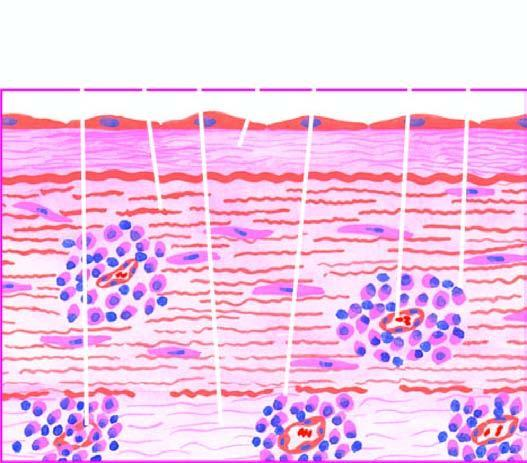what is there of plasma cells, lymphocytes and macrophages?
Answer the question using a single word or phrase. Perivascular infiltrate 